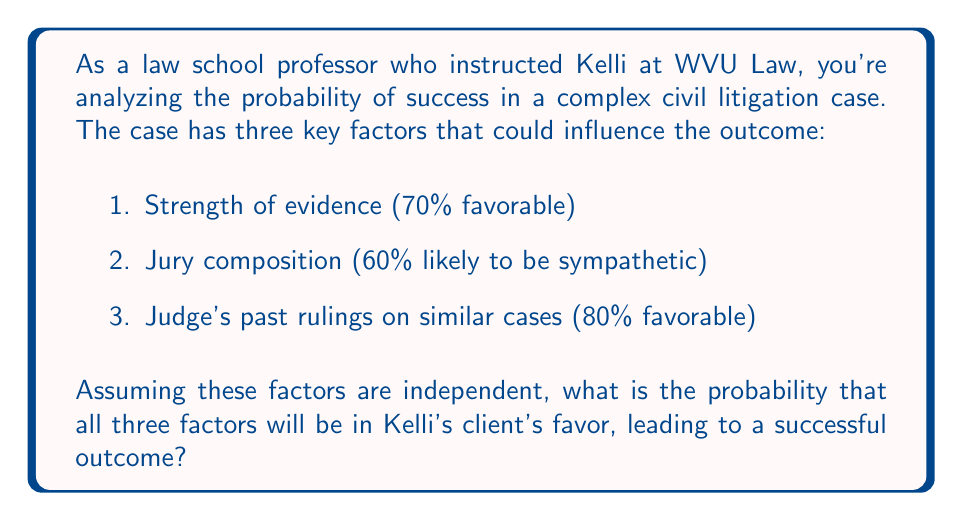Help me with this question. To solve this problem, we need to apply the multiplication rule of probability for independent events. Since the question states that the factors are independent, we can multiply the individual probabilities to find the probability of all factors being favorable.

Let's define our events:
$A$ = Strength of evidence is favorable
$B$ = Jury composition is sympathetic
$C$ = Judge's past rulings are favorable

Given probabilities:
$P(A) = 0.70$
$P(B) = 0.60$
$P(C) = 0.80$

The probability of all three factors being favorable is:

$$P(A \cap B \cap C) = P(A) \times P(B) \times P(C)$$

Substituting the values:

$$P(A \cap B \cap C) = 0.70 \times 0.60 \times 0.80$$

Calculating:

$$P(A \cap B \cap C) = 0.336$$

To convert to a percentage:

$$0.336 \times 100\% = 33.6\%$$

Therefore, the probability that all three factors will be in Kelli's client's favor is 33.6%.
Answer: The probability that all three factors will be in Kelli's client's favor, leading to a successful outcome, is 33.6%. 